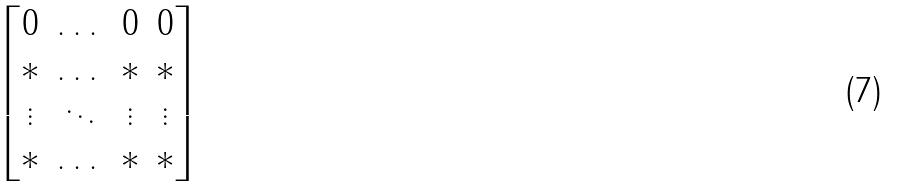<formula> <loc_0><loc_0><loc_500><loc_500>\begin{bmatrix} 0 & \dots & 0 & 0 \\ * & \dots & * & * \\ \vdots & \ddots & \vdots & \vdots \\ * & \dots & * & * \end{bmatrix}</formula> 